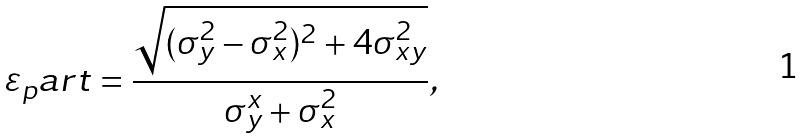Convert formula to latex. <formula><loc_0><loc_0><loc_500><loc_500>\varepsilon _ { p } a r t = \frac { \sqrt { ( \sigma ^ { 2 } _ { y } - \sigma ^ { 2 } _ { x } ) ^ { 2 } + 4 \sigma ^ { 2 } _ { x y } } } { \sigma ^ { x } _ { y } + \sigma ^ { 2 } _ { x } } ,</formula> 